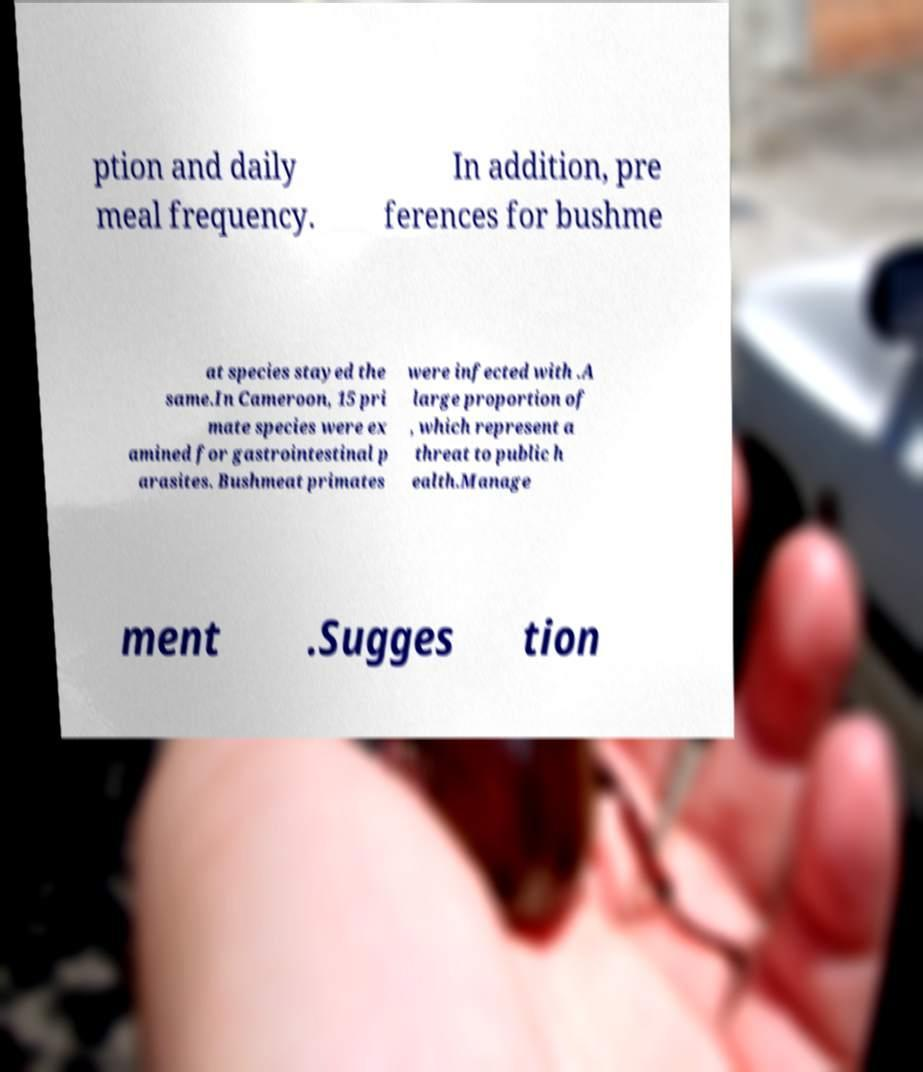Please read and relay the text visible in this image. What does it say? ption and daily meal frequency. In addition, pre ferences for bushme at species stayed the same.In Cameroon, 15 pri mate species were ex amined for gastrointestinal p arasites. Bushmeat primates were infected with .A large proportion of , which represent a threat to public h ealth.Manage ment .Sugges tion 